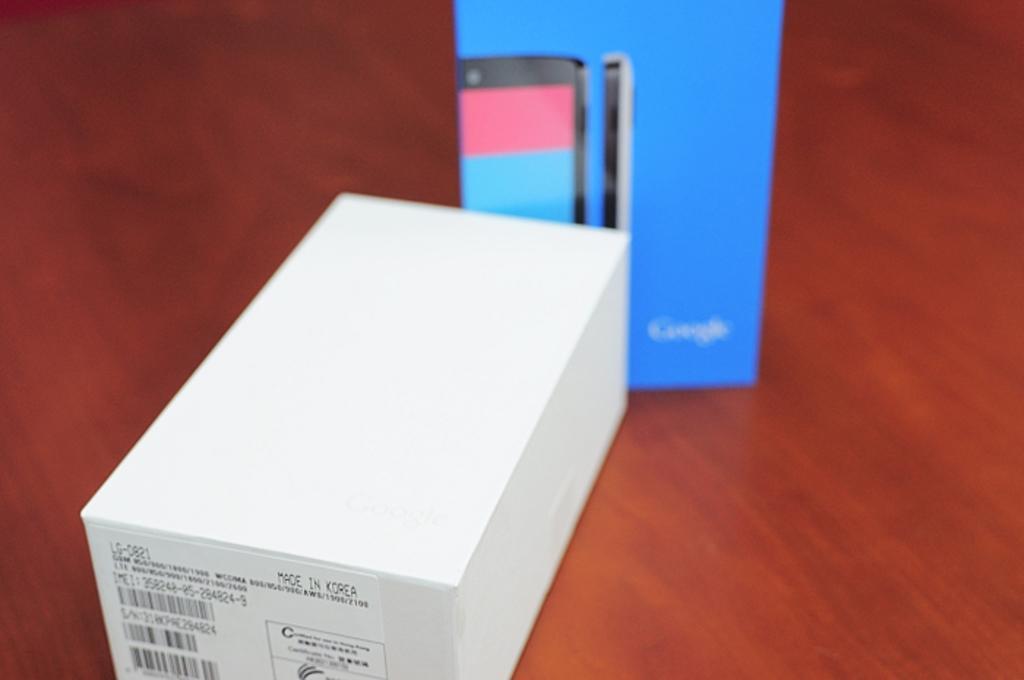<image>
Create a compact narrative representing the image presented. A box for an LG phone that was made in Korea 